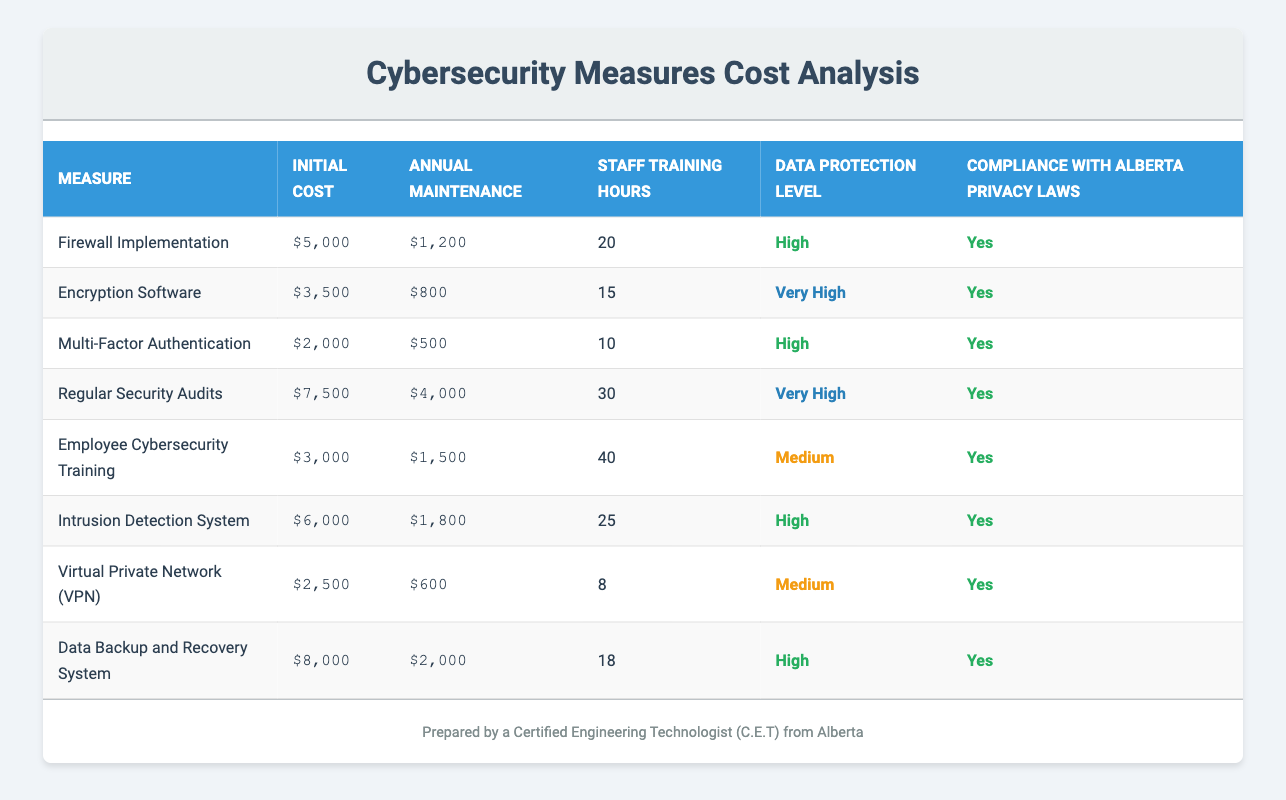What's the initial cost of the Encryption Software? The initial cost for Encryption Software is listed directly in the table under the "Initial Cost" column. It shows $3,500 as the amount required for implementation.
Answer: $3,500 Which cybersecurity measure has the highest data protection level? The table specifies the data protection levels of each measure. Comparing them, "Regular Security Audits" and "Encryption Software" both have the level "Very High," making them the highest.
Answer: Regular Security Audits, Encryption Software What is the total initial cost of all cybersecurity measures? We sum the initial costs of all measures: 5000 + 3500 + 2000 + 7500 + 3000 + 6000 + 2500 + 8000 = 29500.
Answer: $29,500 Is the Multi-Factor Authentication compliant with Alberta privacy laws? The table indicates compliance under the "Compliance with Alberta Privacy Laws" column for each measure. Multi-Factor Authentication has a "Yes" listed, confirming compliance.
Answer: Yes What is the average annual maintenance cost across all measures? To find the average, we first calculate the total annual maintenance costs: 1200 + 800 + 500 + 4000 + 1500 + 1800 + 600 + 2000 = 13900. Then divide that by the number of measures (8): 13900 / 8 = 1737.5.
Answer: $1,737.50 Which measure requires the most staff training hours? The table lists the staff training hours for each measure. "Employee Cybersecurity Training" requires the most at 40 hours, more than any other measures listed.
Answer: Employee Cybersecurity Training What is the minimum initial cost among the cybersecurity measures? By examining the "Initial Cost" column in the table, we see that the lowest cost is for "Multi-Factor Authentication," which is $2,000.
Answer: $2,000 How many measures have a high data protection level or higher? The table indicates that there are 5 measures categorized as "High" or "Very High": "Firewall Implementation," "Encryption Software," "Multi-Factor Authentication," "Regular Security Audits," and "Data Backup and Recovery System."
Answer: 5 